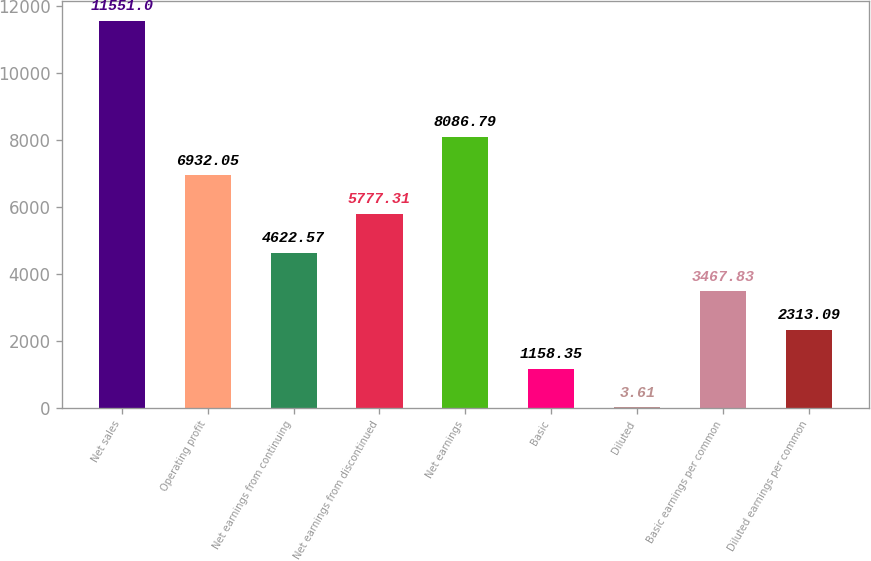<chart> <loc_0><loc_0><loc_500><loc_500><bar_chart><fcel>Net sales<fcel>Operating profit<fcel>Net earnings from continuing<fcel>Net earnings from discontinued<fcel>Net earnings<fcel>Basic<fcel>Diluted<fcel>Basic earnings per common<fcel>Diluted earnings per common<nl><fcel>11551<fcel>6932.05<fcel>4622.57<fcel>5777.31<fcel>8086.79<fcel>1158.35<fcel>3.61<fcel>3467.83<fcel>2313.09<nl></chart> 